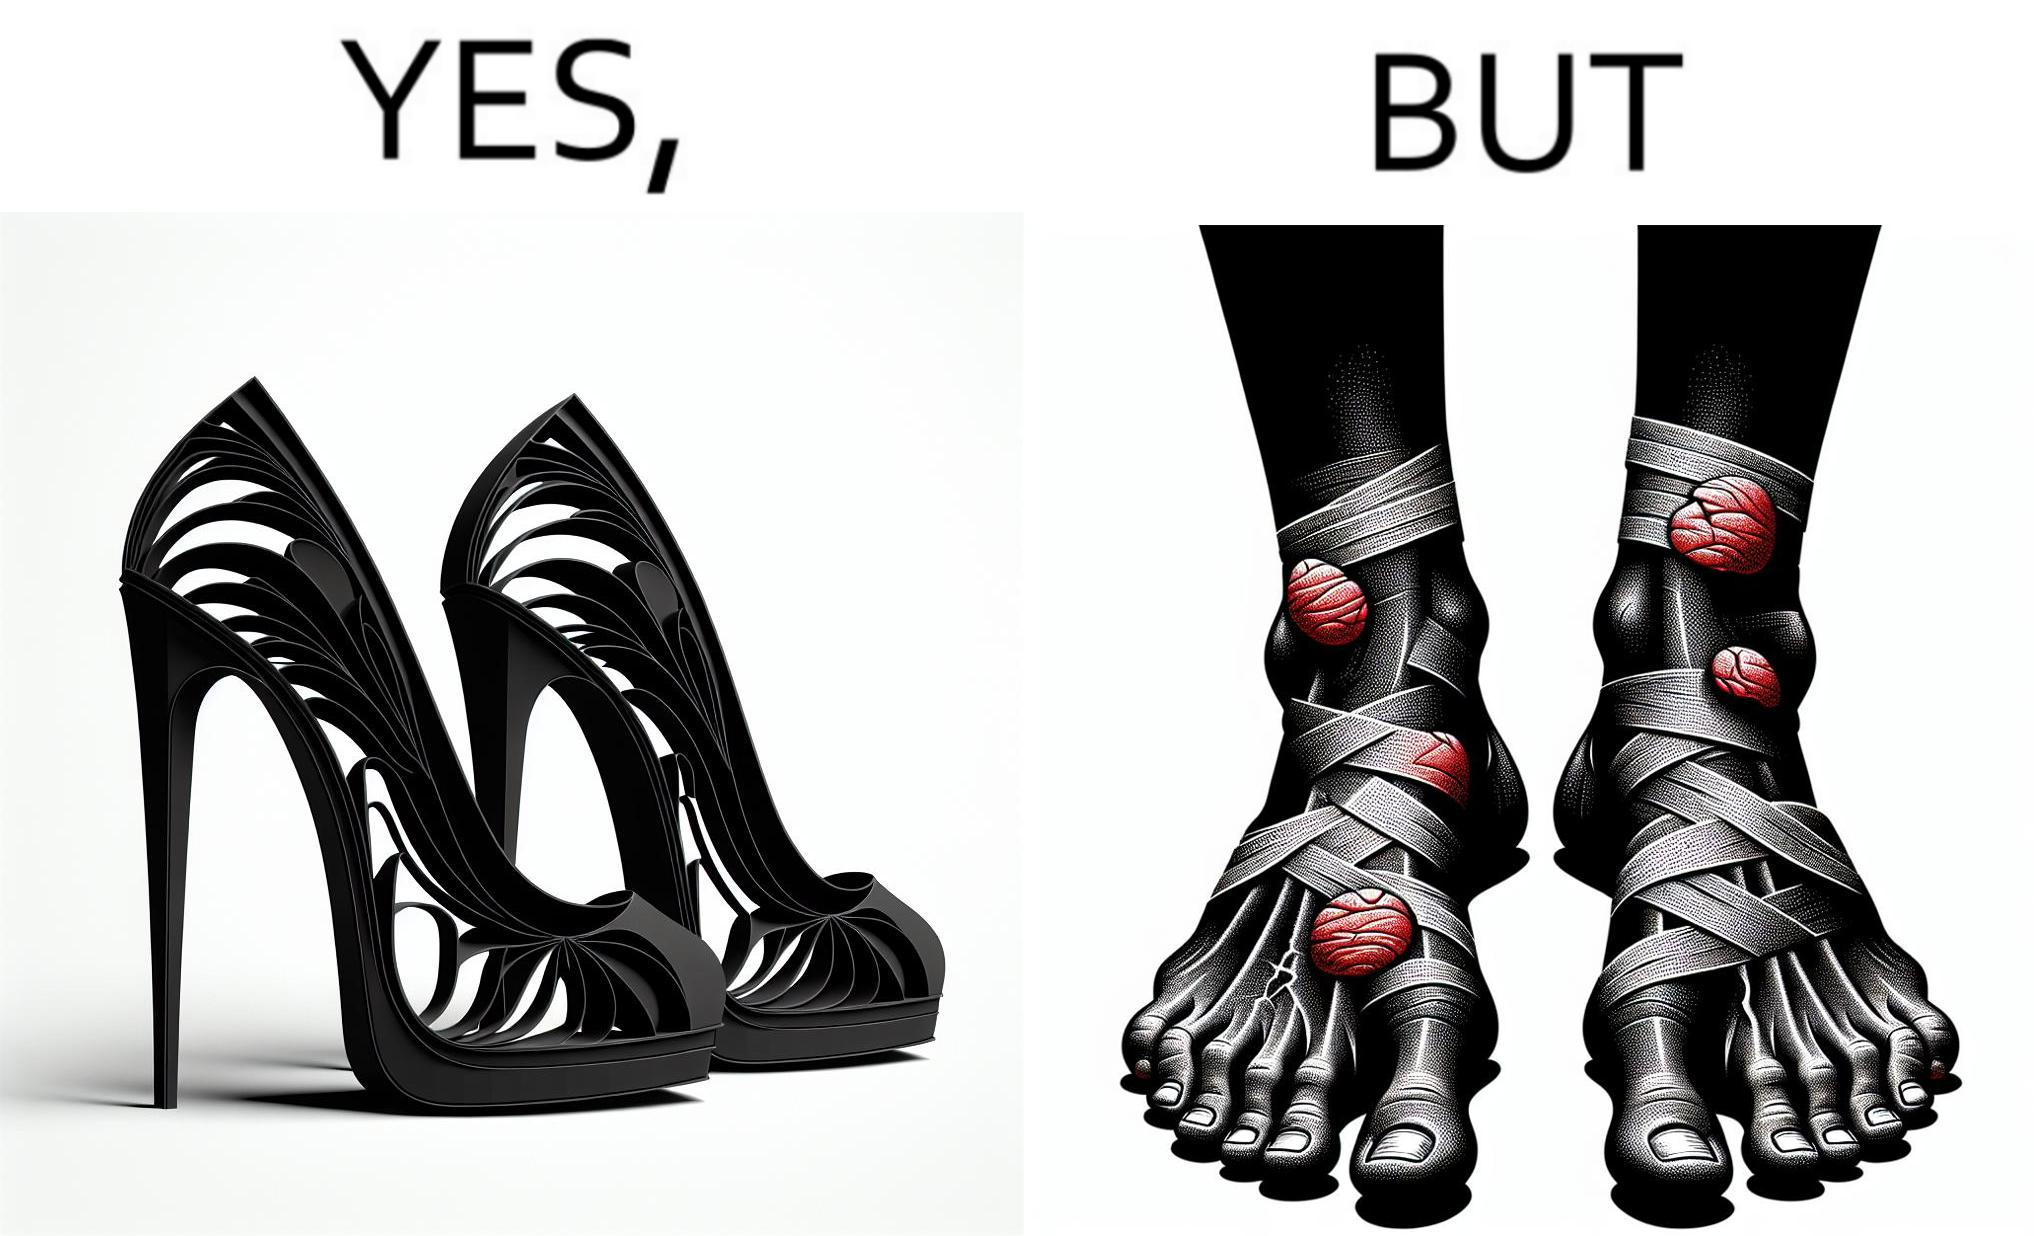Is there satirical content in this image? Yes, this image is satirical. 